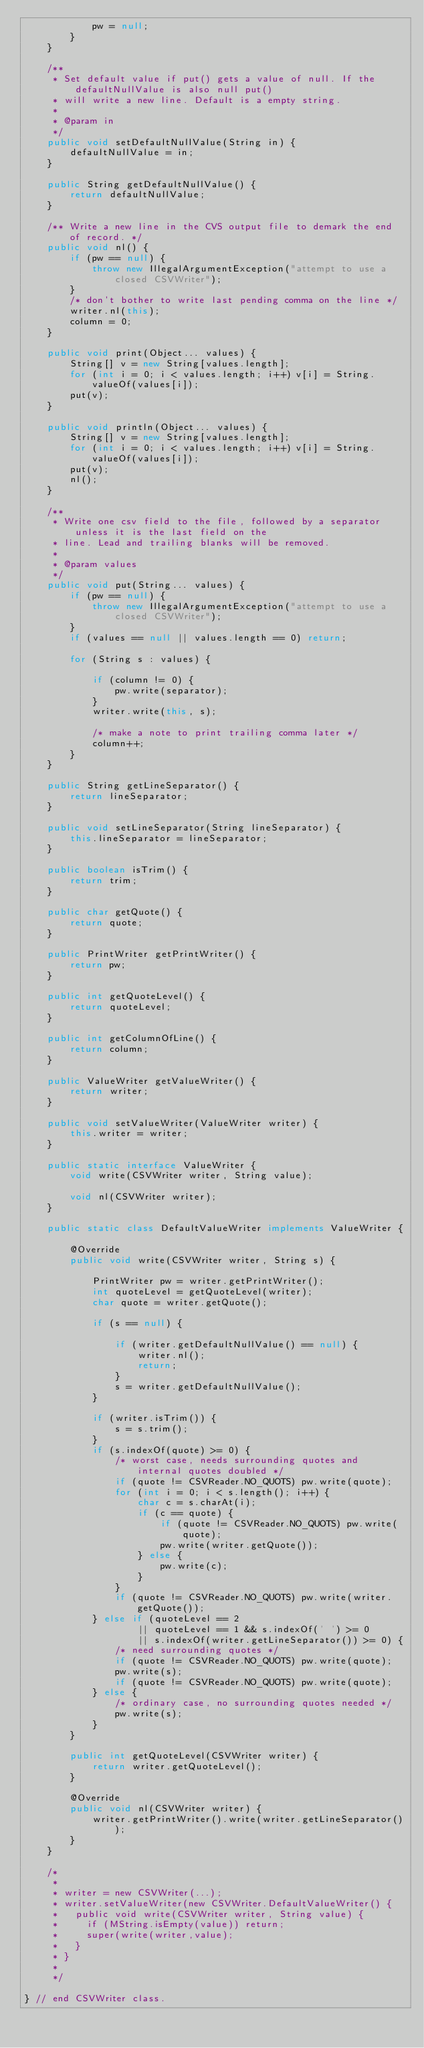<code> <loc_0><loc_0><loc_500><loc_500><_Java_>            pw = null;
        }
    }

    /**
     * Set default value if put() gets a value of null. If the defaultNullValue is also null put()
     * will write a new line. Default is a empty string.
     *
     * @param in
     */
    public void setDefaultNullValue(String in) {
        defaultNullValue = in;
    }

    public String getDefaultNullValue() {
        return defaultNullValue;
    }

    /** Write a new line in the CVS output file to demark the end of record. */
    public void nl() {
        if (pw == null) {
            throw new IllegalArgumentException("attempt to use a closed CSVWriter");
        }
        /* don't bother to write last pending comma on the line */
        writer.nl(this);
        column = 0;
    }

    public void print(Object... values) {
        String[] v = new String[values.length];
        for (int i = 0; i < values.length; i++) v[i] = String.valueOf(values[i]);
        put(v);
    }

    public void println(Object... values) {
        String[] v = new String[values.length];
        for (int i = 0; i < values.length; i++) v[i] = String.valueOf(values[i]);
        put(v);
        nl();
    }

    /**
     * Write one csv field to the file, followed by a separator unless it is the last field on the
     * line. Lead and trailing blanks will be removed.
     *
     * @param values
     */
    public void put(String... values) {
        if (pw == null) {
            throw new IllegalArgumentException("attempt to use a closed CSVWriter");
        }
        if (values == null || values.length == 0) return;

        for (String s : values) {

            if (column != 0) {
                pw.write(separator);
            }
            writer.write(this, s);

            /* make a note to print trailing comma later */
            column++;
        }
    }

    public String getLineSeparator() {
        return lineSeparator;
    }

    public void setLineSeparator(String lineSeparator) {
        this.lineSeparator = lineSeparator;
    }

    public boolean isTrim() {
        return trim;
    }

    public char getQuote() {
        return quote;
    }

    public PrintWriter getPrintWriter() {
        return pw;
    }

    public int getQuoteLevel() {
        return quoteLevel;
    }

    public int getColumnOfLine() {
        return column;
    }

    public ValueWriter getValueWriter() {
        return writer;
    }

    public void setValueWriter(ValueWriter writer) {
        this.writer = writer;
    }

    public static interface ValueWriter {
        void write(CSVWriter writer, String value);

        void nl(CSVWriter writer);
    }

    public static class DefaultValueWriter implements ValueWriter {

        @Override
        public void write(CSVWriter writer, String s) {

            PrintWriter pw = writer.getPrintWriter();
            int quoteLevel = getQuoteLevel(writer);
            char quote = writer.getQuote();

            if (s == null) {

                if (writer.getDefaultNullValue() == null) {
                    writer.nl();
                    return;
                }
                s = writer.getDefaultNullValue();
            }

            if (writer.isTrim()) {
                s = s.trim();
            }
            if (s.indexOf(quote) >= 0) {
                /* worst case, needs surrounding quotes and internal quotes doubled */
                if (quote != CSVReader.NO_QUOTS) pw.write(quote);
                for (int i = 0; i < s.length(); i++) {
                    char c = s.charAt(i);
                    if (c == quote) {
                        if (quote != CSVReader.NO_QUOTS) pw.write(quote);
                        pw.write(writer.getQuote());
                    } else {
                        pw.write(c);
                    }
                }
                if (quote != CSVReader.NO_QUOTS) pw.write(writer.getQuote());
            } else if (quoteLevel == 2
                    || quoteLevel == 1 && s.indexOf(' ') >= 0
                    || s.indexOf(writer.getLineSeparator()) >= 0) {
                /* need surrounding quotes */
                if (quote != CSVReader.NO_QUOTS) pw.write(quote);
                pw.write(s);
                if (quote != CSVReader.NO_QUOTS) pw.write(quote);
            } else {
                /* ordinary case, no surrounding quotes needed */
                pw.write(s);
            }
        }

        public int getQuoteLevel(CSVWriter writer) {
            return writer.getQuoteLevel();
        }

        @Override
        public void nl(CSVWriter writer) {
            writer.getPrintWriter().write(writer.getLineSeparator());
        }
    }

    /*
     *
     * writer = new CSVWriter(...);
     * writer.setValueWriter(new CSVWriter.DefaultValueWriter() {
     *   public void write(CSVWriter writer, String value) {
     *     if (MString.isEmpty(value)) return;
     *     super(write(writer,value);
     *   }
     * }
     *
     */

} // end CSVWriter class.
</code> 